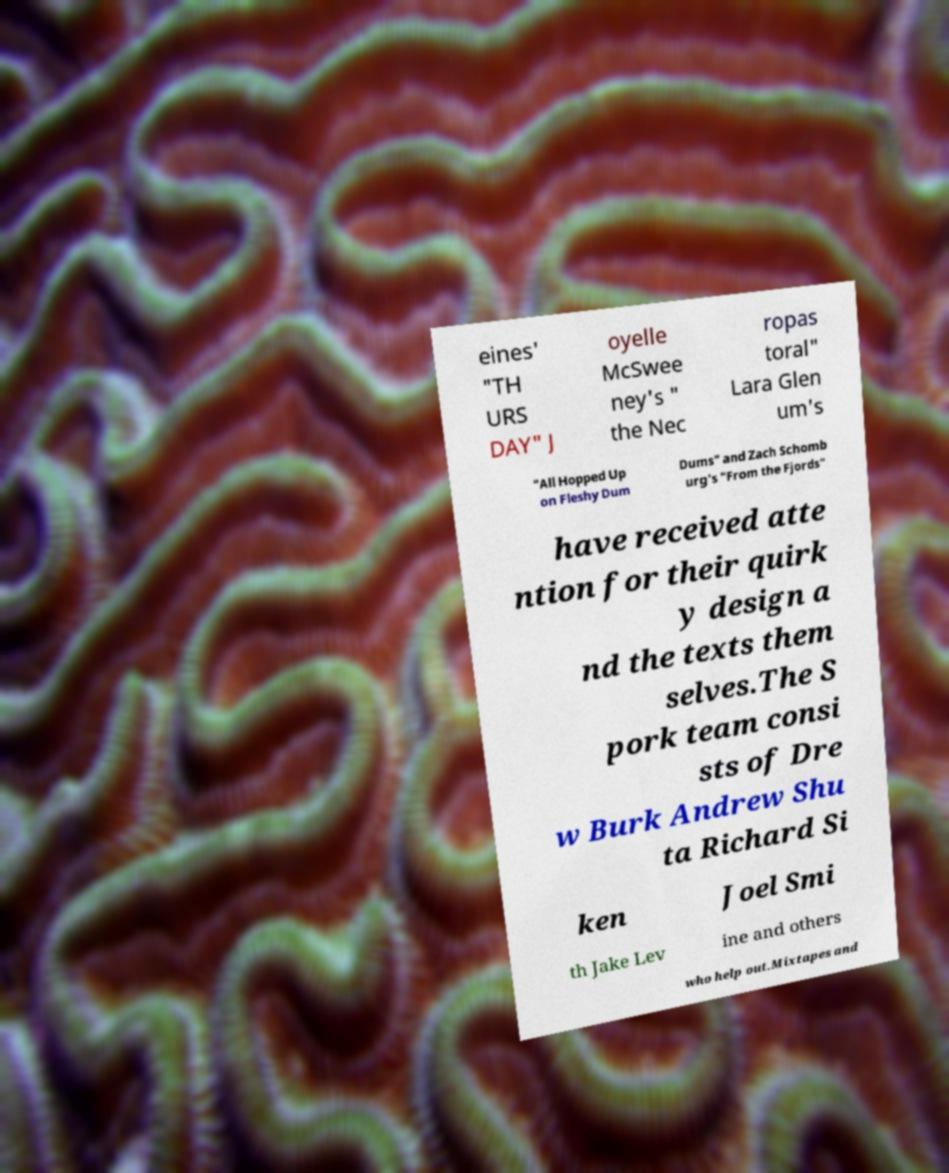Can you accurately transcribe the text from the provided image for me? eines' "TH URS DAY" J oyelle McSwee ney's " the Nec ropas toral" Lara Glen um's "All Hopped Up on Fleshy Dum Dums" and Zach Schomb urg's "From the Fjords" have received atte ntion for their quirk y design a nd the texts them selves.The S pork team consi sts of Dre w Burk Andrew Shu ta Richard Si ken Joel Smi th Jake Lev ine and others who help out.Mixtapes and 